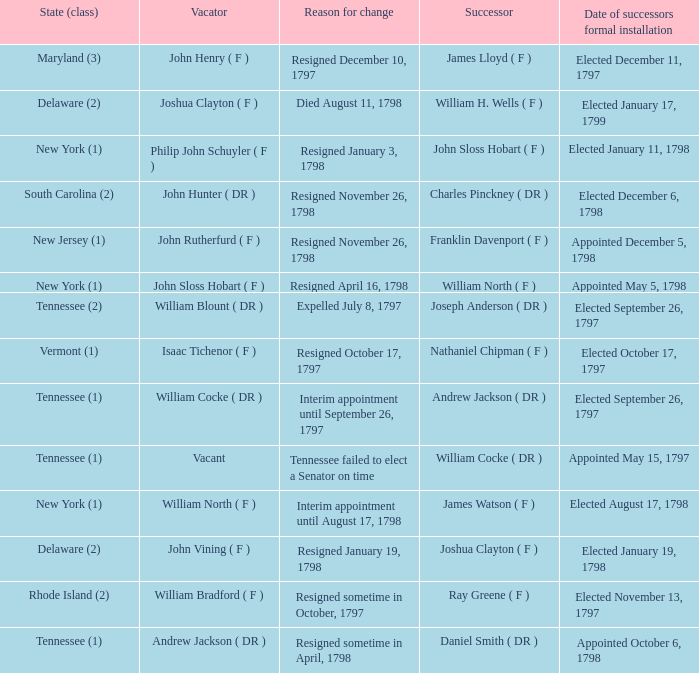What are all the states (class) when the reason for change was resigned November 26, 1798 and the vacator was John Hunter ( DR )? South Carolina (2). 